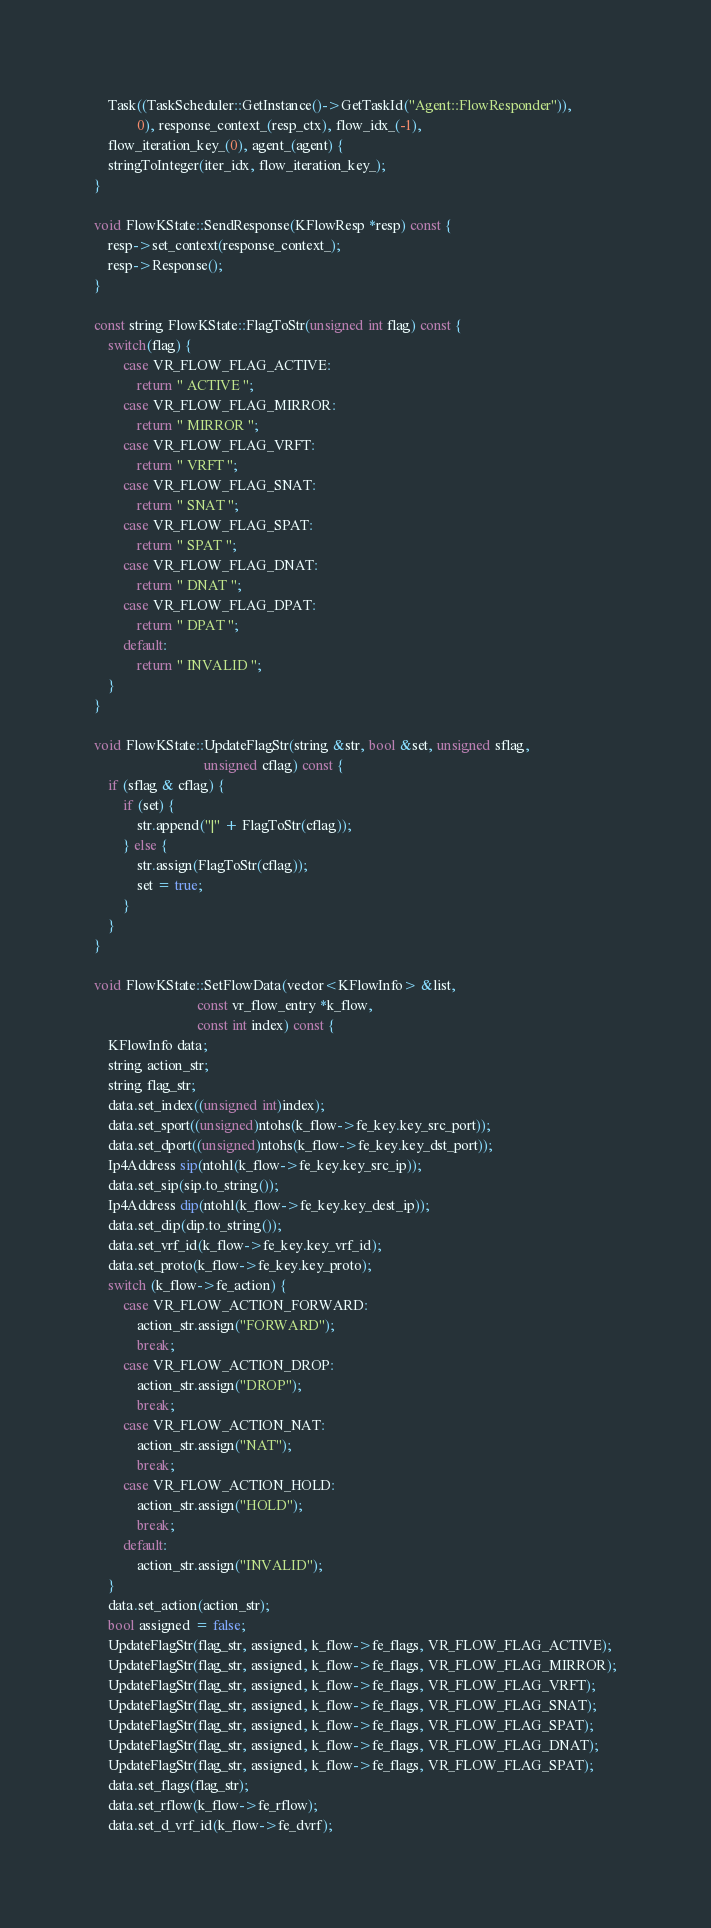Convert code to text. <code><loc_0><loc_0><loc_500><loc_500><_C++_>    Task((TaskScheduler::GetInstance()->GetTaskId("Agent::FlowResponder")),
            0), response_context_(resp_ctx), flow_idx_(-1), 
    flow_iteration_key_(0), agent_(agent) {
    stringToInteger(iter_idx, flow_iteration_key_);
}

void FlowKState::SendResponse(KFlowResp *resp) const {
    resp->set_context(response_context_);
    resp->Response();
}

const string FlowKState::FlagToStr(unsigned int flag) const {
    switch(flag) {
        case VR_FLOW_FLAG_ACTIVE:
            return " ACTIVE ";
        case VR_FLOW_FLAG_MIRROR:
            return " MIRROR ";
        case VR_FLOW_FLAG_VRFT:
            return " VRFT ";
        case VR_FLOW_FLAG_SNAT:
            return " SNAT ";
        case VR_FLOW_FLAG_SPAT:
            return " SPAT ";
        case VR_FLOW_FLAG_DNAT:
            return " DNAT ";
        case VR_FLOW_FLAG_DPAT:
            return " DPAT ";
        default:
            return " INVALID ";
    }
}

void FlowKState::UpdateFlagStr(string &str, bool &set, unsigned sflag, 
                               unsigned cflag) const {
    if (sflag & cflag) {
        if (set) {
            str.append("|" + FlagToStr(cflag));
        } else {
            str.assign(FlagToStr(cflag));
            set = true;
        }
    }
}

void FlowKState::SetFlowData(vector<KFlowInfo> &list, 
                             const vr_flow_entry *k_flow, 
                             const int index) const {
    KFlowInfo data;
    string action_str;
    string flag_str;
    data.set_index((unsigned int)index);
    data.set_sport((unsigned)ntohs(k_flow->fe_key.key_src_port));
    data.set_dport((unsigned)ntohs(k_flow->fe_key.key_dst_port));
    Ip4Address sip(ntohl(k_flow->fe_key.key_src_ip));
    data.set_sip(sip.to_string());
    Ip4Address dip(ntohl(k_flow->fe_key.key_dest_ip));
    data.set_dip(dip.to_string());
    data.set_vrf_id(k_flow->fe_key.key_vrf_id);
    data.set_proto(k_flow->fe_key.key_proto);
    switch (k_flow->fe_action) {
        case VR_FLOW_ACTION_FORWARD:
            action_str.assign("FORWARD");
            break;
        case VR_FLOW_ACTION_DROP:
            action_str.assign("DROP");
            break;
        case VR_FLOW_ACTION_NAT:
            action_str.assign("NAT");
            break;
        case VR_FLOW_ACTION_HOLD:
            action_str.assign("HOLD");
            break;
        default:
            action_str.assign("INVALID");
    }
    data.set_action(action_str);
    bool assigned = false;
    UpdateFlagStr(flag_str, assigned, k_flow->fe_flags, VR_FLOW_FLAG_ACTIVE);
    UpdateFlagStr(flag_str, assigned, k_flow->fe_flags, VR_FLOW_FLAG_MIRROR);
    UpdateFlagStr(flag_str, assigned, k_flow->fe_flags, VR_FLOW_FLAG_VRFT);
    UpdateFlagStr(flag_str, assigned, k_flow->fe_flags, VR_FLOW_FLAG_SNAT);
    UpdateFlagStr(flag_str, assigned, k_flow->fe_flags, VR_FLOW_FLAG_SPAT);
    UpdateFlagStr(flag_str, assigned, k_flow->fe_flags, VR_FLOW_FLAG_DNAT);
    UpdateFlagStr(flag_str, assigned, k_flow->fe_flags, VR_FLOW_FLAG_SPAT);
    data.set_flags(flag_str);
    data.set_rflow(k_flow->fe_rflow);
    data.set_d_vrf_id(k_flow->fe_dvrf);</code> 